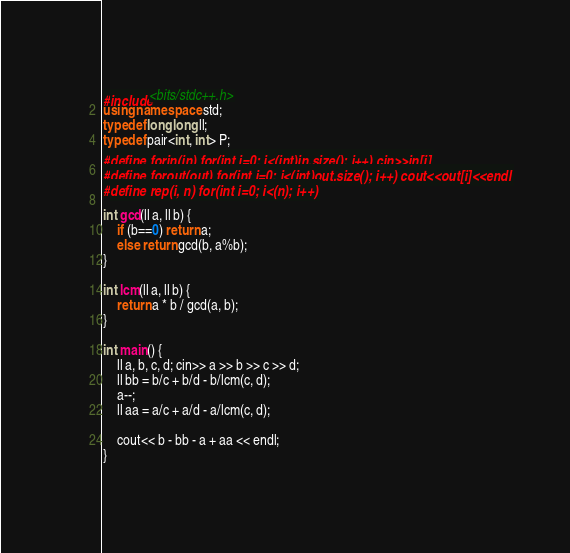<code> <loc_0><loc_0><loc_500><loc_500><_C++_>#include<bits/stdc++.h>
using namespace std;
typedef long long ll;
typedef pair<int, int> P;
#define forin(in) for(int i=0; i<(int)in.size(); i++) cin>>in[i]
#define forout(out) for(int i=0; i<(int)out.size(); i++) cout<<out[i]<<endl
#define rep(i, n) for(int i=0; i<(n); i++)

int gcd(ll a, ll b) {
    if (b==0) return a;
    else return gcd(b, a%b);
}

int lcm(ll a, ll b) {
    return a * b / gcd(a, b);
}

int main() {
    ll a, b, c, d; cin>> a >> b >> c >> d;
    ll bb = b/c + b/d - b/lcm(c, d);
    a--;
    ll aa = a/c + a/d - a/lcm(c, d);

    cout<< b - bb - a + aa << endl;
}
</code> 